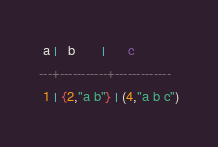Convert code to text. <code><loc_0><loc_0><loc_500><loc_500><_SQL_> a |   b       |      c
---+-----------+-------------
 1 | {2,"a b"} | (4,"a b c")
</code> 